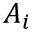<formula> <loc_0><loc_0><loc_500><loc_500>A _ { i }</formula> 